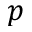<formula> <loc_0><loc_0><loc_500><loc_500>p</formula> 